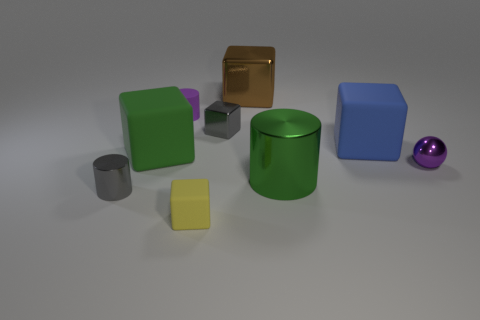Are the large brown thing and the small yellow thing made of the same material?
Your answer should be compact. No. What number of spheres are either yellow objects or small purple rubber objects?
Offer a terse response. 0. There is a purple object to the left of the tiny gray metallic thing to the right of the matte cube in front of the purple metal thing; how big is it?
Your answer should be very brief. Small. What size is the yellow object that is the same shape as the big blue matte thing?
Keep it short and to the point. Small. There is a big brown metallic object; how many purple matte cylinders are left of it?
Make the answer very short. 1. There is a small metal thing behind the blue block; is it the same color as the large cylinder?
Keep it short and to the point. No. What number of red things are either metal spheres or cubes?
Keep it short and to the point. 0. The cube that is left of the tiny purple object behind the blue block is what color?
Offer a terse response. Green. What material is the tiny object that is the same color as the tiny shiny cube?
Your answer should be very brief. Metal. There is a tiny cylinder to the right of the tiny gray cylinder; what is its color?
Make the answer very short. Purple. 